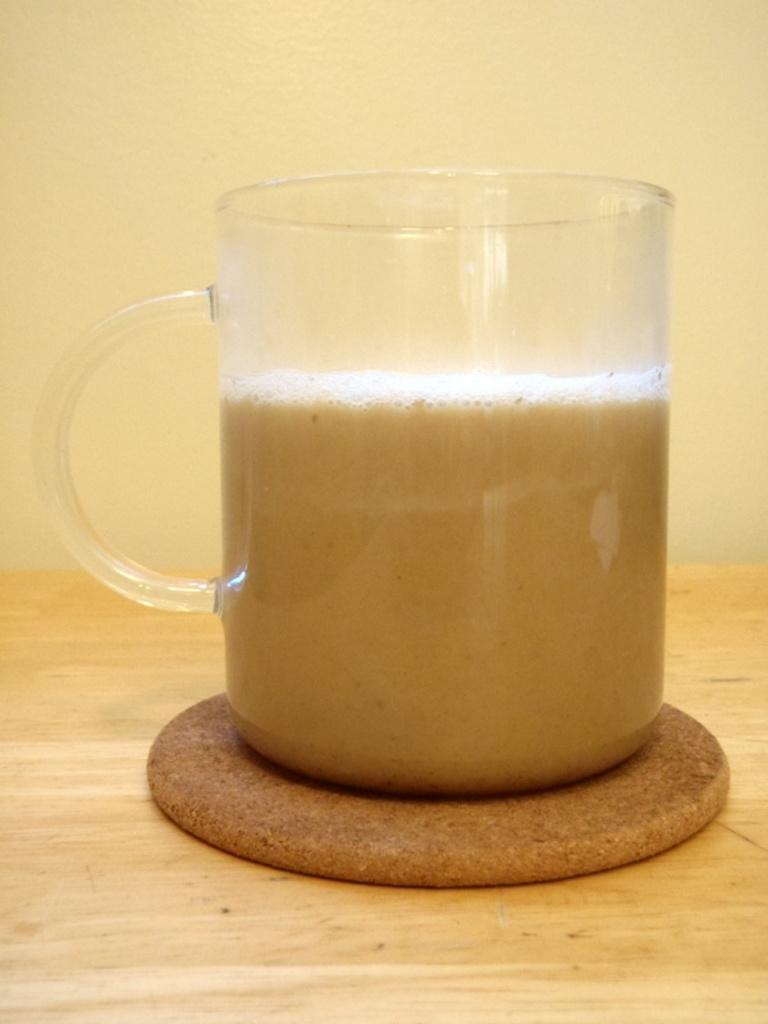What is in the mug that is visible in the image? There is a mug with liquid in the image. What is located below the mug? There is an object below the mug. What type of surface is at the bottom of the image? There is a wooden surface at the bottom of the image. What can be seen behind the wooden surface in the image? There is a wall visible in the image. What type of paste is being used to strengthen the muscle in the image? There is no paste or muscle present in the image; it only features a mug with liquid, an object below the mug, a wooden surface, and a wall. 